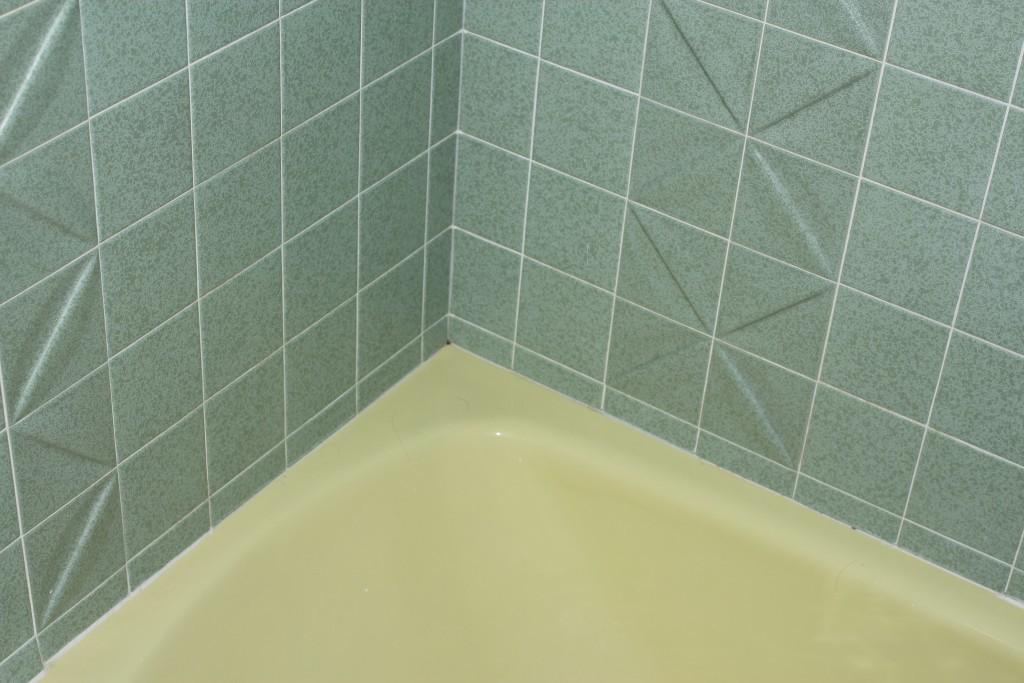How would you summarize this image in a sentence or two? On the background of the picture we can see tiles in sea green colour. This is a sink or i guess it's similar to a bath tub which is light yellowish in colour. 